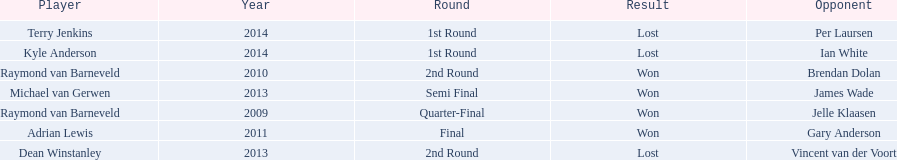Who are all the players? Raymond van Barneveld, Raymond van Barneveld, Adrian Lewis, Dean Winstanley, Michael van Gerwen, Terry Jenkins, Kyle Anderson. When did they play? 2009, 2010, 2011, 2013, 2013, 2014, 2014. And which player played in 2011? Adrian Lewis. 